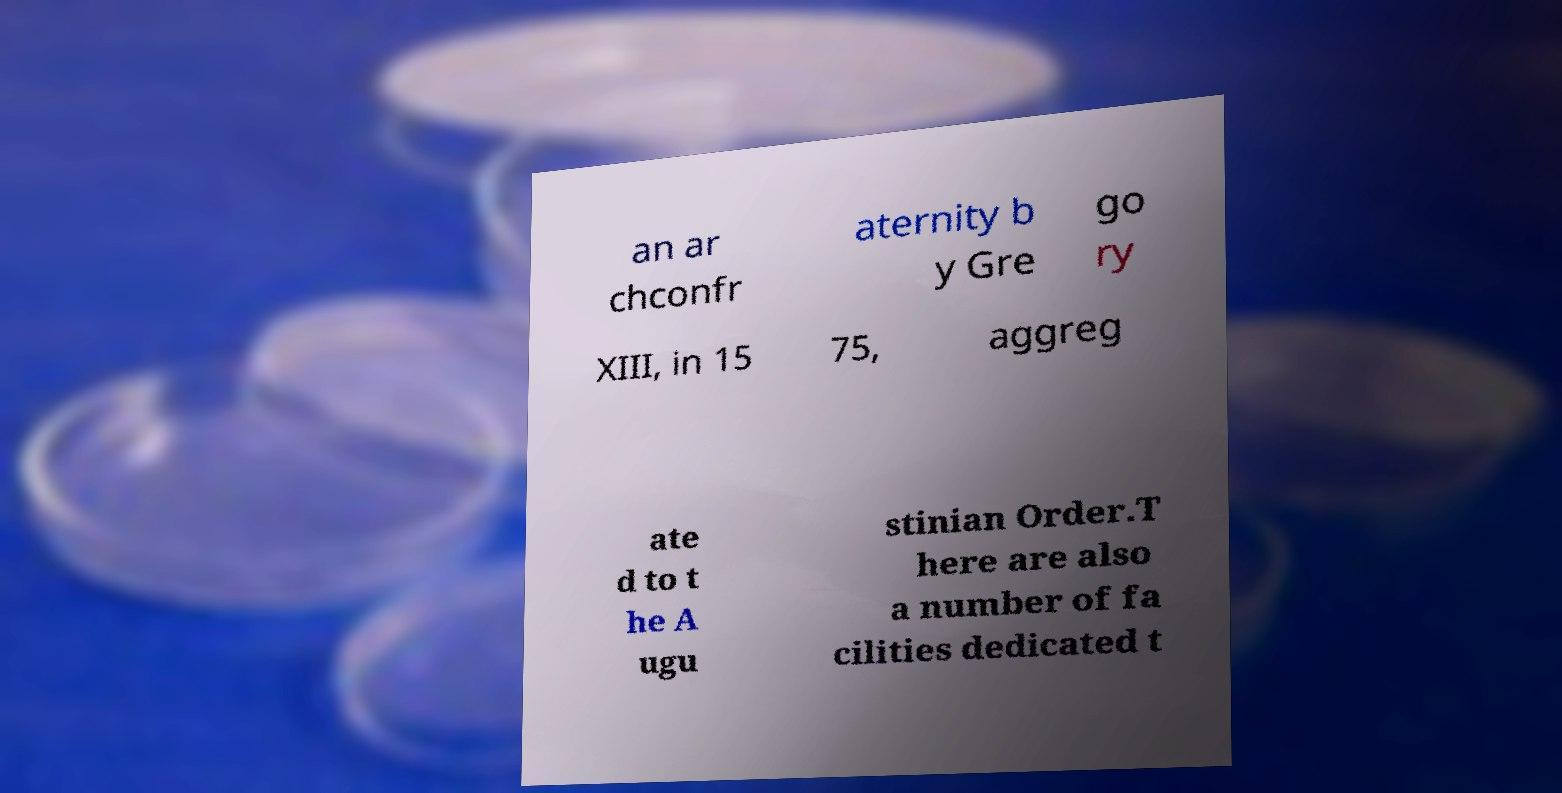Can you accurately transcribe the text from the provided image for me? an ar chconfr aternity b y Gre go ry XIII, in 15 75, aggreg ate d to t he A ugu stinian Order.T here are also a number of fa cilities dedicated t 